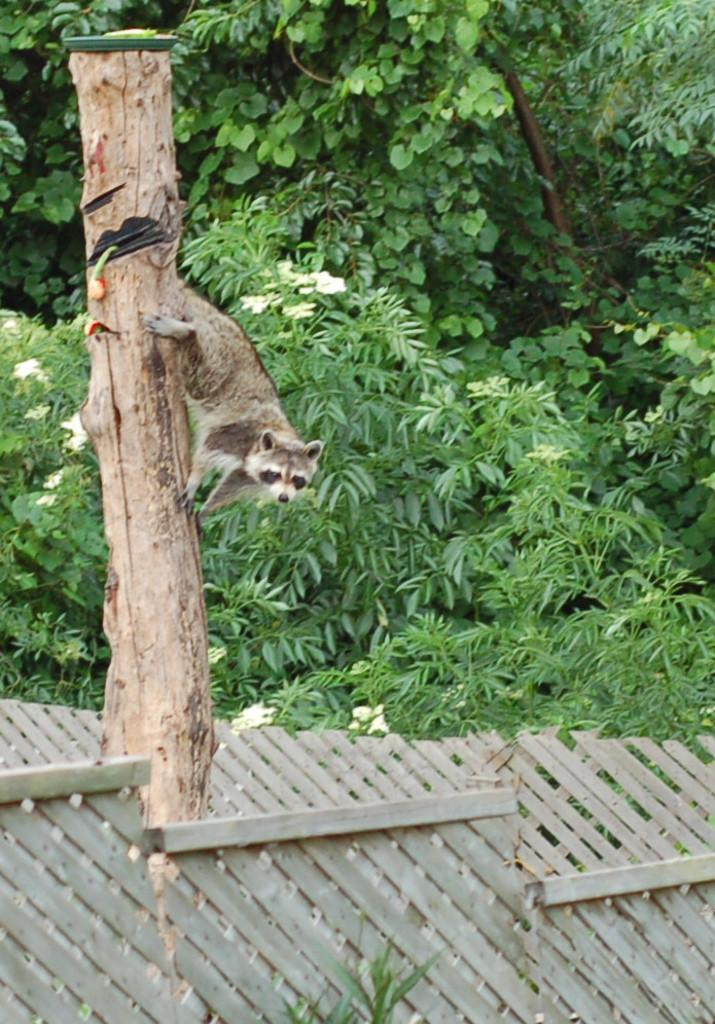What type of animal can be seen in the image? There is an animal in the image, but its specific species cannot be determined from the provided facts. What colors are present on the animal? The animal has white, brown, and black colors. Where is the animal located in the image? The animal is on a branch. What type of vegetation is visible in the image? There are green trees visible in the image. What type of fencing can be seen in the image? There is a cream-colored fencing in the image. What type of soap is being used to clean the animal in the image? There is no soap or cleaning activity present in the image. What season is depicted in the image, given the presence of spring flowers? The provided facts do not mention any flowers or seasons, so it cannot be determined from the image. 